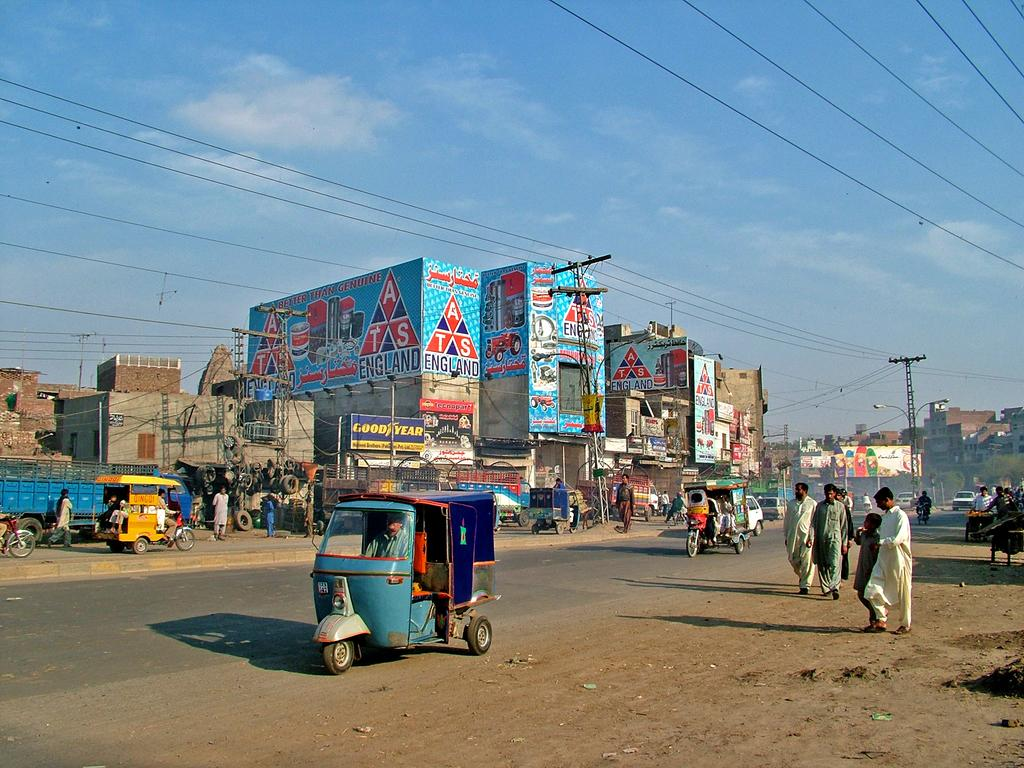What can be seen in the foreground of the image? There are people and vehicles in the foreground of the image. What is visible in the background of the image? There are buildings, poles, wires, posters, and the sky in the background of the image. What type of brick is used to build the cobweb in the image? There is no cobweb present in the image, and therefore no bricks are involved. What kind of meal is being prepared in the image? There is no meal preparation visible in the image. 